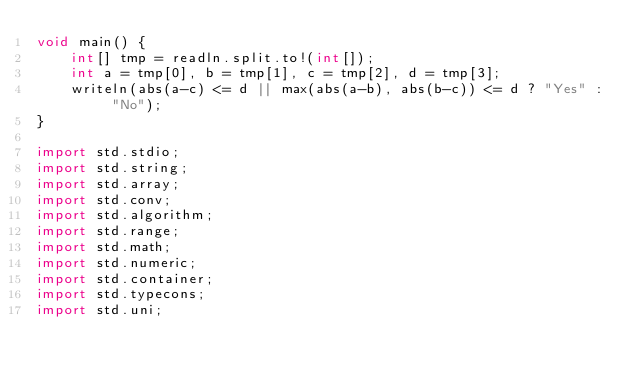Convert code to text. <code><loc_0><loc_0><loc_500><loc_500><_D_>void main() {
    int[] tmp = readln.split.to!(int[]);
    int a = tmp[0], b = tmp[1], c = tmp[2], d = tmp[3];
    writeln(abs(a-c) <= d || max(abs(a-b), abs(b-c)) <= d ? "Yes" : "No");
}

import std.stdio;
import std.string;
import std.array;
import std.conv;
import std.algorithm;
import std.range;
import std.math;
import std.numeric;
import std.container;
import std.typecons;
import std.uni;</code> 